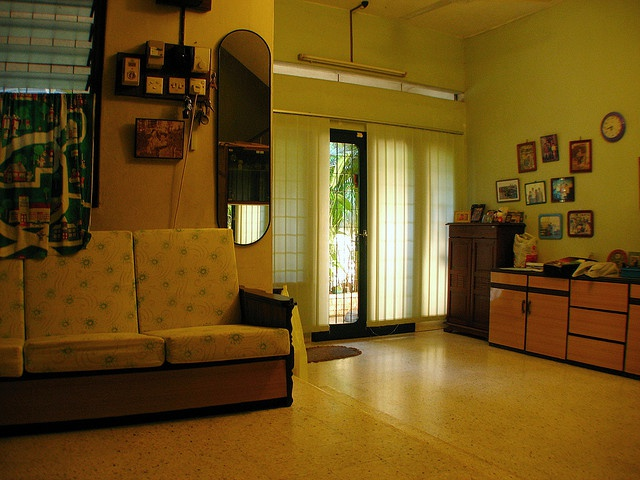Describe the objects in this image and their specific colors. I can see couch in black, maroon, and olive tones and clock in black, olive, and maroon tones in this image. 